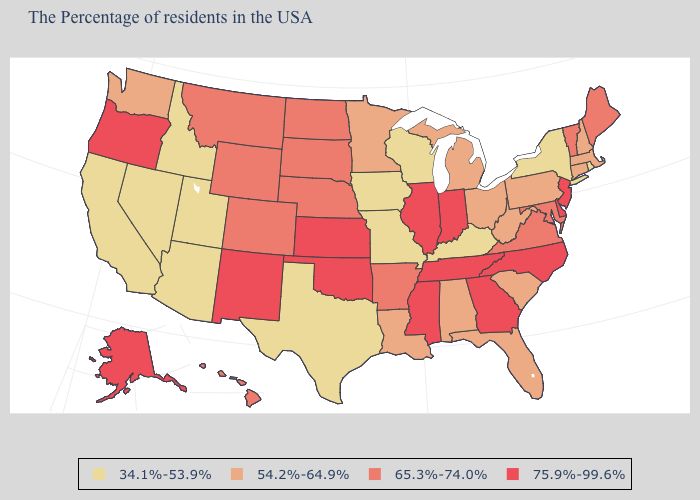What is the highest value in states that border Minnesota?
Write a very short answer. 65.3%-74.0%. Does the first symbol in the legend represent the smallest category?
Concise answer only. Yes. What is the value of Connecticut?
Quick response, please. 54.2%-64.9%. Which states have the lowest value in the USA?
Keep it brief. Rhode Island, New York, Kentucky, Wisconsin, Missouri, Iowa, Texas, Utah, Arizona, Idaho, Nevada, California. What is the highest value in states that border Louisiana?
Quick response, please. 75.9%-99.6%. Among the states that border North Carolina , which have the highest value?
Answer briefly. Georgia, Tennessee. What is the value of Arkansas?
Answer briefly. 65.3%-74.0%. Does the first symbol in the legend represent the smallest category?
Write a very short answer. Yes. What is the lowest value in the USA?
Write a very short answer. 34.1%-53.9%. Does Louisiana have a lower value than Iowa?
Concise answer only. No. What is the value of Vermont?
Answer briefly. 65.3%-74.0%. Does New York have the lowest value in the Northeast?
Give a very brief answer. Yes. Does the map have missing data?
Be succinct. No. Does California have the lowest value in the USA?
Quick response, please. Yes. 